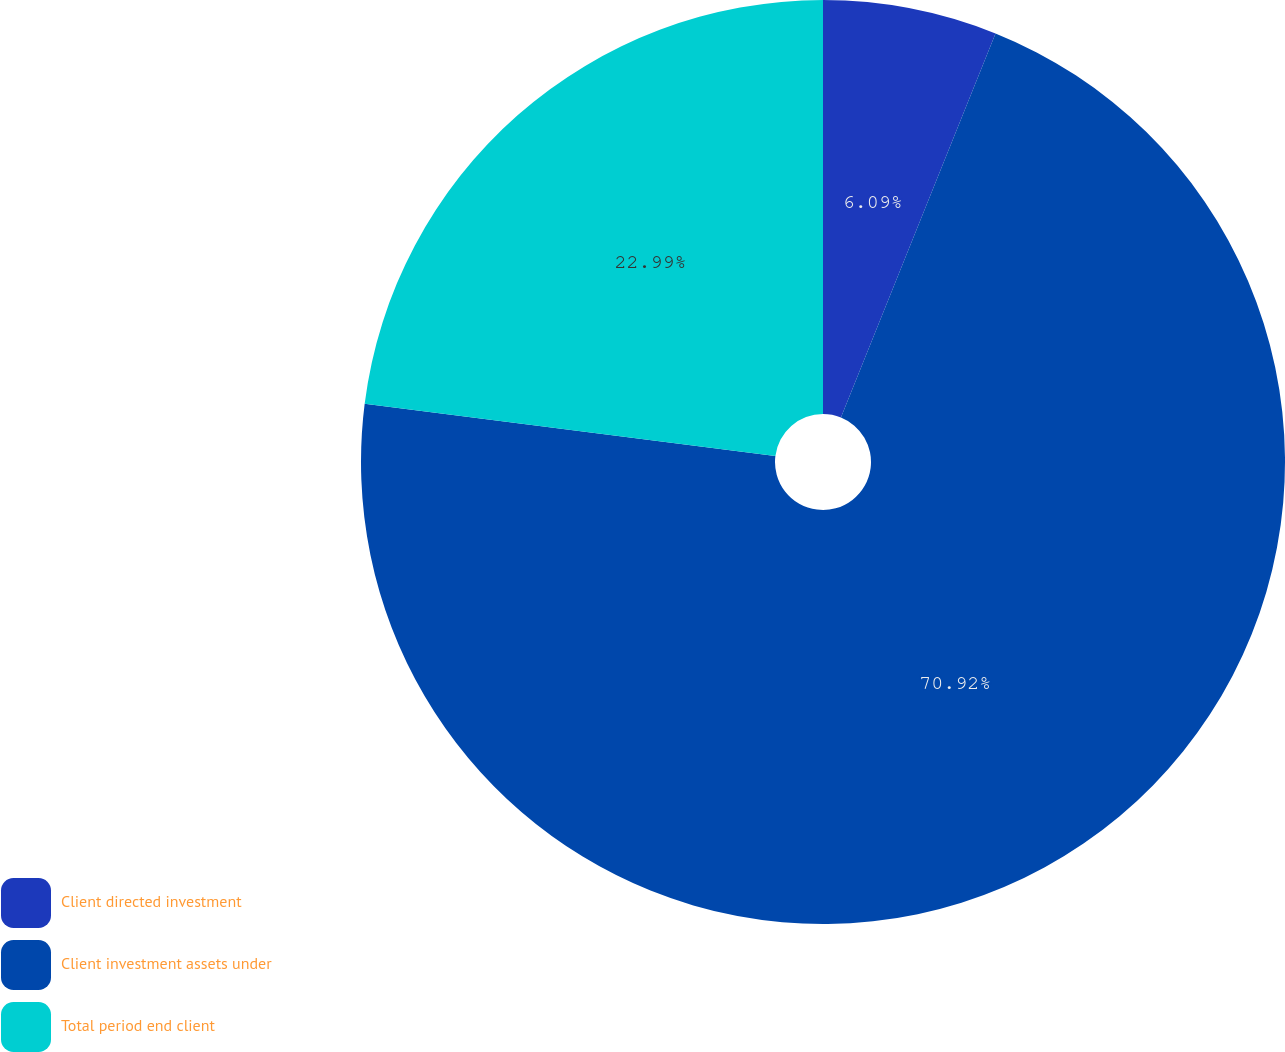<chart> <loc_0><loc_0><loc_500><loc_500><pie_chart><fcel>Client directed investment<fcel>Client investment assets under<fcel>Total period end client<nl><fcel>6.09%<fcel>70.91%<fcel>22.99%<nl></chart> 